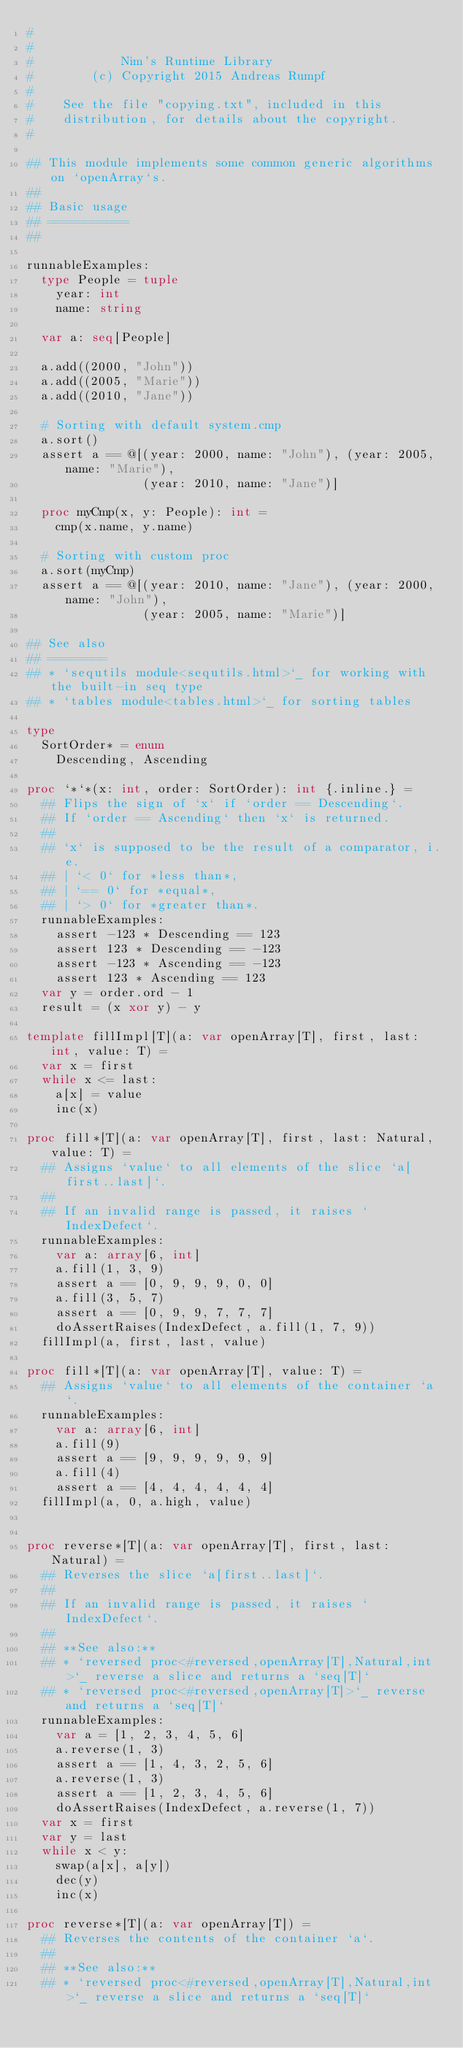<code> <loc_0><loc_0><loc_500><loc_500><_Nim_>#
#
#            Nim's Runtime Library
#        (c) Copyright 2015 Andreas Rumpf
#
#    See the file "copying.txt", included in this
#    distribution, for details about the copyright.
#

## This module implements some common generic algorithms on `openArray`s.
##
## Basic usage
## ===========
##

runnableExamples:
  type People = tuple
    year: int
    name: string

  var a: seq[People]

  a.add((2000, "John"))
  a.add((2005, "Marie"))
  a.add((2010, "Jane"))

  # Sorting with default system.cmp
  a.sort()
  assert a == @[(year: 2000, name: "John"), (year: 2005, name: "Marie"),
                (year: 2010, name: "Jane")]

  proc myCmp(x, y: People): int =
    cmp(x.name, y.name)

  # Sorting with custom proc
  a.sort(myCmp)
  assert a == @[(year: 2010, name: "Jane"), (year: 2000, name: "John"),
                (year: 2005, name: "Marie")]

## See also
## ========
## * `sequtils module<sequtils.html>`_ for working with the built-in seq type
## * `tables module<tables.html>`_ for sorting tables

type
  SortOrder* = enum
    Descending, Ascending

proc `*`*(x: int, order: SortOrder): int {.inline.} =
  ## Flips the sign of `x` if `order == Descending`.
  ## If `order == Ascending` then `x` is returned.
  ##
  ## `x` is supposed to be the result of a comparator, i.e.
  ## | `< 0` for *less than*,
  ## | `== 0` for *equal*,
  ## | `> 0` for *greater than*.
  runnableExamples:
    assert -123 * Descending == 123
    assert 123 * Descending == -123
    assert -123 * Ascending == -123
    assert 123 * Ascending == 123
  var y = order.ord - 1
  result = (x xor y) - y

template fillImpl[T](a: var openArray[T], first, last: int, value: T) =
  var x = first
  while x <= last:
    a[x] = value
    inc(x)

proc fill*[T](a: var openArray[T], first, last: Natural, value: T) =
  ## Assigns `value` to all elements of the slice `a[first..last]`.
  ##
  ## If an invalid range is passed, it raises `IndexDefect`.
  runnableExamples:
    var a: array[6, int]
    a.fill(1, 3, 9)
    assert a == [0, 9, 9, 9, 0, 0]
    a.fill(3, 5, 7)
    assert a == [0, 9, 9, 7, 7, 7]
    doAssertRaises(IndexDefect, a.fill(1, 7, 9))
  fillImpl(a, first, last, value)

proc fill*[T](a: var openArray[T], value: T) =
  ## Assigns `value` to all elements of the container `a`.
  runnableExamples:
    var a: array[6, int]
    a.fill(9)
    assert a == [9, 9, 9, 9, 9, 9]
    a.fill(4)
    assert a == [4, 4, 4, 4, 4, 4]
  fillImpl(a, 0, a.high, value)


proc reverse*[T](a: var openArray[T], first, last: Natural) =
  ## Reverses the slice `a[first..last]`.
  ##
  ## If an invalid range is passed, it raises `IndexDefect`.
  ##
  ## **See also:**
  ## * `reversed proc<#reversed,openArray[T],Natural,int>`_ reverse a slice and returns a `seq[T]`
  ## * `reversed proc<#reversed,openArray[T]>`_ reverse and returns a `seq[T]`
  runnableExamples:
    var a = [1, 2, 3, 4, 5, 6]
    a.reverse(1, 3)
    assert a == [1, 4, 3, 2, 5, 6]
    a.reverse(1, 3)
    assert a == [1, 2, 3, 4, 5, 6]
    doAssertRaises(IndexDefect, a.reverse(1, 7))
  var x = first
  var y = last
  while x < y:
    swap(a[x], a[y])
    dec(y)
    inc(x)

proc reverse*[T](a: var openArray[T]) =
  ## Reverses the contents of the container `a`.
  ##
  ## **See also:**
  ## * `reversed proc<#reversed,openArray[T],Natural,int>`_ reverse a slice and returns a `seq[T]`</code> 